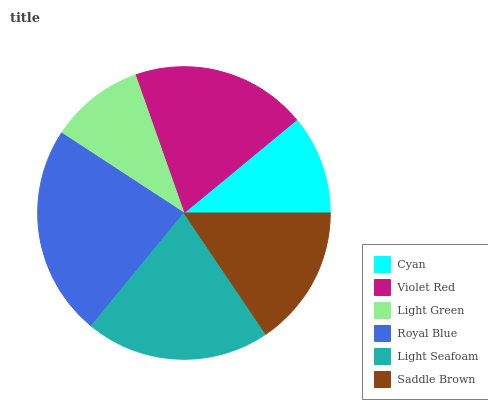Is Light Green the minimum?
Answer yes or no. Yes. Is Royal Blue the maximum?
Answer yes or no. Yes. Is Violet Red the minimum?
Answer yes or no. No. Is Violet Red the maximum?
Answer yes or no. No. Is Violet Red greater than Cyan?
Answer yes or no. Yes. Is Cyan less than Violet Red?
Answer yes or no. Yes. Is Cyan greater than Violet Red?
Answer yes or no. No. Is Violet Red less than Cyan?
Answer yes or no. No. Is Violet Red the high median?
Answer yes or no. Yes. Is Saddle Brown the low median?
Answer yes or no. Yes. Is Cyan the high median?
Answer yes or no. No. Is Violet Red the low median?
Answer yes or no. No. 